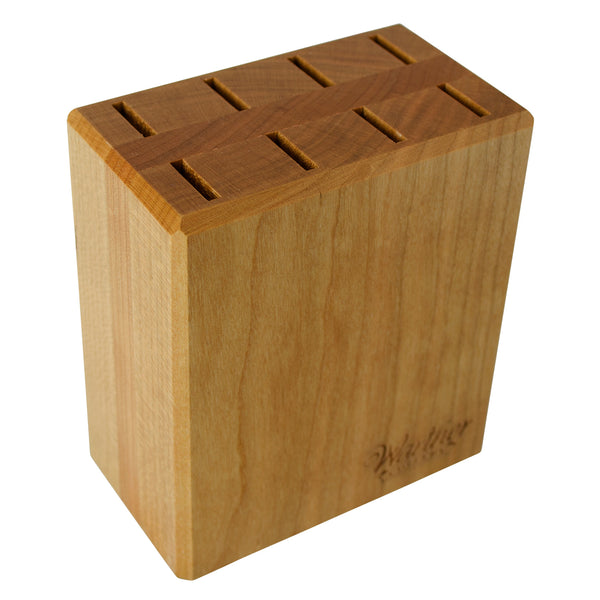How does the design of this knife holder compare to more modern, metal or acrylic holders in terms of aesthetic and functionality? The wooden design of this knife holder offers a classic and warm aesthetic compared to the often sleek, industrial look of metal or minimalist vibe of acrylic holders. Functionally, wood provides a durable, self-healing surface that doesn’t dull knife blades as quickly as metal might. The thick wood construction can be more robust at supporting the weight of larger, heavier knives without toppling, providing a sturdy, time-tested storage solution. 